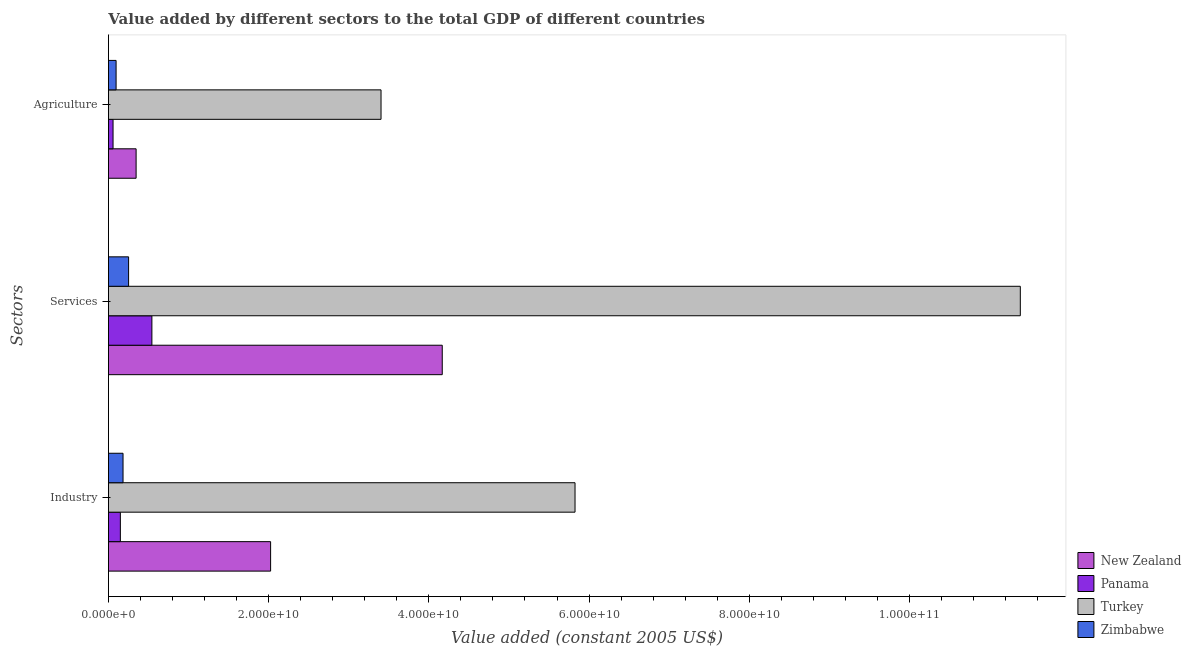Are the number of bars per tick equal to the number of legend labels?
Offer a very short reply. Yes. Are the number of bars on each tick of the Y-axis equal?
Your response must be concise. Yes. How many bars are there on the 3rd tick from the bottom?
Offer a terse response. 4. What is the label of the 1st group of bars from the top?
Keep it short and to the point. Agriculture. What is the value added by services in New Zealand?
Offer a very short reply. 4.17e+1. Across all countries, what is the maximum value added by agricultural sector?
Keep it short and to the point. 3.40e+1. Across all countries, what is the minimum value added by services?
Your answer should be compact. 2.52e+09. In which country was the value added by agricultural sector maximum?
Offer a very short reply. Turkey. In which country was the value added by agricultural sector minimum?
Your answer should be compact. Panama. What is the total value added by agricultural sector in the graph?
Provide a succinct answer. 3.90e+1. What is the difference between the value added by industrial sector in Zimbabwe and that in New Zealand?
Your response must be concise. -1.84e+1. What is the difference between the value added by industrial sector in Turkey and the value added by agricultural sector in Zimbabwe?
Offer a terse response. 5.73e+1. What is the average value added by industrial sector per country?
Your answer should be very brief. 2.05e+1. What is the difference between the value added by agricultural sector and value added by services in Turkey?
Your answer should be very brief. -7.98e+1. In how many countries, is the value added by agricultural sector greater than 64000000000 US$?
Your answer should be very brief. 0. What is the ratio of the value added by industrial sector in Zimbabwe to that in Panama?
Give a very brief answer. 1.22. Is the difference between the value added by agricultural sector in Zimbabwe and New Zealand greater than the difference between the value added by services in Zimbabwe and New Zealand?
Offer a terse response. Yes. What is the difference between the highest and the second highest value added by services?
Your answer should be compact. 7.22e+1. What is the difference between the highest and the lowest value added by services?
Your answer should be compact. 1.11e+11. In how many countries, is the value added by industrial sector greater than the average value added by industrial sector taken over all countries?
Offer a terse response. 1. What does the 1st bar from the top in Services represents?
Your answer should be compact. Zimbabwe. What does the 4th bar from the bottom in Industry represents?
Your response must be concise. Zimbabwe. Is it the case that in every country, the sum of the value added by industrial sector and value added by services is greater than the value added by agricultural sector?
Offer a terse response. Yes. How many bars are there?
Your response must be concise. 12. Are the values on the major ticks of X-axis written in scientific E-notation?
Offer a very short reply. Yes. Does the graph contain grids?
Provide a succinct answer. No. Where does the legend appear in the graph?
Offer a very short reply. Bottom right. How many legend labels are there?
Provide a succinct answer. 4. How are the legend labels stacked?
Offer a very short reply. Vertical. What is the title of the graph?
Provide a succinct answer. Value added by different sectors to the total GDP of different countries. What is the label or title of the X-axis?
Provide a succinct answer. Value added (constant 2005 US$). What is the label or title of the Y-axis?
Your answer should be very brief. Sectors. What is the Value added (constant 2005 US$) of New Zealand in Industry?
Keep it short and to the point. 2.02e+1. What is the Value added (constant 2005 US$) in Panama in Industry?
Your answer should be very brief. 1.49e+09. What is the Value added (constant 2005 US$) in Turkey in Industry?
Keep it short and to the point. 5.82e+1. What is the Value added (constant 2005 US$) of Zimbabwe in Industry?
Make the answer very short. 1.82e+09. What is the Value added (constant 2005 US$) in New Zealand in Services?
Keep it short and to the point. 4.17e+1. What is the Value added (constant 2005 US$) of Panama in Services?
Provide a succinct answer. 5.43e+09. What is the Value added (constant 2005 US$) of Turkey in Services?
Your response must be concise. 1.14e+11. What is the Value added (constant 2005 US$) of Zimbabwe in Services?
Offer a very short reply. 2.52e+09. What is the Value added (constant 2005 US$) in New Zealand in Agriculture?
Keep it short and to the point. 3.45e+09. What is the Value added (constant 2005 US$) in Panama in Agriculture?
Your answer should be compact. 5.77e+08. What is the Value added (constant 2005 US$) of Turkey in Agriculture?
Give a very brief answer. 3.40e+1. What is the Value added (constant 2005 US$) of Zimbabwe in Agriculture?
Your response must be concise. 9.56e+08. Across all Sectors, what is the maximum Value added (constant 2005 US$) in New Zealand?
Ensure brevity in your answer.  4.17e+1. Across all Sectors, what is the maximum Value added (constant 2005 US$) of Panama?
Make the answer very short. 5.43e+09. Across all Sectors, what is the maximum Value added (constant 2005 US$) in Turkey?
Give a very brief answer. 1.14e+11. Across all Sectors, what is the maximum Value added (constant 2005 US$) in Zimbabwe?
Give a very brief answer. 2.52e+09. Across all Sectors, what is the minimum Value added (constant 2005 US$) in New Zealand?
Offer a terse response. 3.45e+09. Across all Sectors, what is the minimum Value added (constant 2005 US$) in Panama?
Ensure brevity in your answer.  5.77e+08. Across all Sectors, what is the minimum Value added (constant 2005 US$) in Turkey?
Your answer should be compact. 3.40e+1. Across all Sectors, what is the minimum Value added (constant 2005 US$) in Zimbabwe?
Your answer should be compact. 9.56e+08. What is the total Value added (constant 2005 US$) in New Zealand in the graph?
Keep it short and to the point. 6.54e+1. What is the total Value added (constant 2005 US$) of Panama in the graph?
Provide a succinct answer. 7.49e+09. What is the total Value added (constant 2005 US$) of Turkey in the graph?
Your response must be concise. 2.06e+11. What is the total Value added (constant 2005 US$) in Zimbabwe in the graph?
Keep it short and to the point. 5.30e+09. What is the difference between the Value added (constant 2005 US$) in New Zealand in Industry and that in Services?
Provide a short and direct response. -2.14e+1. What is the difference between the Value added (constant 2005 US$) in Panama in Industry and that in Services?
Keep it short and to the point. -3.94e+09. What is the difference between the Value added (constant 2005 US$) in Turkey in Industry and that in Services?
Provide a short and direct response. -5.56e+1. What is the difference between the Value added (constant 2005 US$) of Zimbabwe in Industry and that in Services?
Make the answer very short. -6.93e+08. What is the difference between the Value added (constant 2005 US$) in New Zealand in Industry and that in Agriculture?
Make the answer very short. 1.68e+1. What is the difference between the Value added (constant 2005 US$) of Panama in Industry and that in Agriculture?
Your response must be concise. 9.13e+08. What is the difference between the Value added (constant 2005 US$) of Turkey in Industry and that in Agriculture?
Make the answer very short. 2.42e+1. What is the difference between the Value added (constant 2005 US$) in Zimbabwe in Industry and that in Agriculture?
Your response must be concise. 8.67e+08. What is the difference between the Value added (constant 2005 US$) in New Zealand in Services and that in Agriculture?
Ensure brevity in your answer.  3.82e+1. What is the difference between the Value added (constant 2005 US$) in Panama in Services and that in Agriculture?
Give a very brief answer. 4.85e+09. What is the difference between the Value added (constant 2005 US$) of Turkey in Services and that in Agriculture?
Your answer should be compact. 7.98e+1. What is the difference between the Value added (constant 2005 US$) in Zimbabwe in Services and that in Agriculture?
Provide a short and direct response. 1.56e+09. What is the difference between the Value added (constant 2005 US$) of New Zealand in Industry and the Value added (constant 2005 US$) of Panama in Services?
Give a very brief answer. 1.48e+1. What is the difference between the Value added (constant 2005 US$) of New Zealand in Industry and the Value added (constant 2005 US$) of Turkey in Services?
Ensure brevity in your answer.  -9.36e+1. What is the difference between the Value added (constant 2005 US$) of New Zealand in Industry and the Value added (constant 2005 US$) of Zimbabwe in Services?
Offer a terse response. 1.77e+1. What is the difference between the Value added (constant 2005 US$) of Panama in Industry and the Value added (constant 2005 US$) of Turkey in Services?
Your answer should be very brief. -1.12e+11. What is the difference between the Value added (constant 2005 US$) of Panama in Industry and the Value added (constant 2005 US$) of Zimbabwe in Services?
Your answer should be compact. -1.03e+09. What is the difference between the Value added (constant 2005 US$) of Turkey in Industry and the Value added (constant 2005 US$) of Zimbabwe in Services?
Your answer should be compact. 5.57e+1. What is the difference between the Value added (constant 2005 US$) of New Zealand in Industry and the Value added (constant 2005 US$) of Panama in Agriculture?
Your answer should be compact. 1.97e+1. What is the difference between the Value added (constant 2005 US$) in New Zealand in Industry and the Value added (constant 2005 US$) in Turkey in Agriculture?
Keep it short and to the point. -1.38e+1. What is the difference between the Value added (constant 2005 US$) of New Zealand in Industry and the Value added (constant 2005 US$) of Zimbabwe in Agriculture?
Offer a terse response. 1.93e+1. What is the difference between the Value added (constant 2005 US$) of Panama in Industry and the Value added (constant 2005 US$) of Turkey in Agriculture?
Provide a succinct answer. -3.25e+1. What is the difference between the Value added (constant 2005 US$) of Panama in Industry and the Value added (constant 2005 US$) of Zimbabwe in Agriculture?
Make the answer very short. 5.34e+08. What is the difference between the Value added (constant 2005 US$) of Turkey in Industry and the Value added (constant 2005 US$) of Zimbabwe in Agriculture?
Ensure brevity in your answer.  5.73e+1. What is the difference between the Value added (constant 2005 US$) of New Zealand in Services and the Value added (constant 2005 US$) of Panama in Agriculture?
Ensure brevity in your answer.  4.11e+1. What is the difference between the Value added (constant 2005 US$) in New Zealand in Services and the Value added (constant 2005 US$) in Turkey in Agriculture?
Keep it short and to the point. 7.64e+09. What is the difference between the Value added (constant 2005 US$) in New Zealand in Services and the Value added (constant 2005 US$) in Zimbabwe in Agriculture?
Offer a terse response. 4.07e+1. What is the difference between the Value added (constant 2005 US$) in Panama in Services and the Value added (constant 2005 US$) in Turkey in Agriculture?
Your answer should be compact. -2.86e+1. What is the difference between the Value added (constant 2005 US$) of Panama in Services and the Value added (constant 2005 US$) of Zimbabwe in Agriculture?
Give a very brief answer. 4.47e+09. What is the difference between the Value added (constant 2005 US$) of Turkey in Services and the Value added (constant 2005 US$) of Zimbabwe in Agriculture?
Your answer should be very brief. 1.13e+11. What is the average Value added (constant 2005 US$) of New Zealand per Sectors?
Provide a short and direct response. 2.18e+1. What is the average Value added (constant 2005 US$) of Panama per Sectors?
Provide a short and direct response. 2.50e+09. What is the average Value added (constant 2005 US$) in Turkey per Sectors?
Offer a terse response. 6.87e+1. What is the average Value added (constant 2005 US$) in Zimbabwe per Sectors?
Your answer should be very brief. 1.77e+09. What is the difference between the Value added (constant 2005 US$) in New Zealand and Value added (constant 2005 US$) in Panama in Industry?
Provide a succinct answer. 1.88e+1. What is the difference between the Value added (constant 2005 US$) in New Zealand and Value added (constant 2005 US$) in Turkey in Industry?
Offer a very short reply. -3.80e+1. What is the difference between the Value added (constant 2005 US$) of New Zealand and Value added (constant 2005 US$) of Zimbabwe in Industry?
Provide a short and direct response. 1.84e+1. What is the difference between the Value added (constant 2005 US$) in Panama and Value added (constant 2005 US$) in Turkey in Industry?
Offer a very short reply. -5.68e+1. What is the difference between the Value added (constant 2005 US$) of Panama and Value added (constant 2005 US$) of Zimbabwe in Industry?
Your response must be concise. -3.33e+08. What is the difference between the Value added (constant 2005 US$) of Turkey and Value added (constant 2005 US$) of Zimbabwe in Industry?
Give a very brief answer. 5.64e+1. What is the difference between the Value added (constant 2005 US$) of New Zealand and Value added (constant 2005 US$) of Panama in Services?
Give a very brief answer. 3.62e+1. What is the difference between the Value added (constant 2005 US$) in New Zealand and Value added (constant 2005 US$) in Turkey in Services?
Provide a succinct answer. -7.22e+1. What is the difference between the Value added (constant 2005 US$) of New Zealand and Value added (constant 2005 US$) of Zimbabwe in Services?
Your answer should be very brief. 3.92e+1. What is the difference between the Value added (constant 2005 US$) of Panama and Value added (constant 2005 US$) of Turkey in Services?
Offer a very short reply. -1.08e+11. What is the difference between the Value added (constant 2005 US$) of Panama and Value added (constant 2005 US$) of Zimbabwe in Services?
Your answer should be very brief. 2.91e+09. What is the difference between the Value added (constant 2005 US$) in Turkey and Value added (constant 2005 US$) in Zimbabwe in Services?
Make the answer very short. 1.11e+11. What is the difference between the Value added (constant 2005 US$) in New Zealand and Value added (constant 2005 US$) in Panama in Agriculture?
Your answer should be very brief. 2.88e+09. What is the difference between the Value added (constant 2005 US$) in New Zealand and Value added (constant 2005 US$) in Turkey in Agriculture?
Your answer should be very brief. -3.06e+1. What is the difference between the Value added (constant 2005 US$) in New Zealand and Value added (constant 2005 US$) in Zimbabwe in Agriculture?
Offer a terse response. 2.50e+09. What is the difference between the Value added (constant 2005 US$) in Panama and Value added (constant 2005 US$) in Turkey in Agriculture?
Your answer should be compact. -3.35e+1. What is the difference between the Value added (constant 2005 US$) in Panama and Value added (constant 2005 US$) in Zimbabwe in Agriculture?
Provide a succinct answer. -3.79e+08. What is the difference between the Value added (constant 2005 US$) in Turkey and Value added (constant 2005 US$) in Zimbabwe in Agriculture?
Provide a succinct answer. 3.31e+1. What is the ratio of the Value added (constant 2005 US$) in New Zealand in Industry to that in Services?
Provide a succinct answer. 0.49. What is the ratio of the Value added (constant 2005 US$) of Panama in Industry to that in Services?
Give a very brief answer. 0.27. What is the ratio of the Value added (constant 2005 US$) in Turkey in Industry to that in Services?
Provide a short and direct response. 0.51. What is the ratio of the Value added (constant 2005 US$) of Zimbabwe in Industry to that in Services?
Offer a terse response. 0.72. What is the ratio of the Value added (constant 2005 US$) in New Zealand in Industry to that in Agriculture?
Your answer should be very brief. 5.86. What is the ratio of the Value added (constant 2005 US$) in Panama in Industry to that in Agriculture?
Ensure brevity in your answer.  2.58. What is the ratio of the Value added (constant 2005 US$) of Turkey in Industry to that in Agriculture?
Your answer should be very brief. 1.71. What is the ratio of the Value added (constant 2005 US$) of Zimbabwe in Industry to that in Agriculture?
Your answer should be very brief. 1.91. What is the ratio of the Value added (constant 2005 US$) in New Zealand in Services to that in Agriculture?
Offer a very short reply. 12.06. What is the ratio of the Value added (constant 2005 US$) of Panama in Services to that in Agriculture?
Give a very brief answer. 9.4. What is the ratio of the Value added (constant 2005 US$) of Turkey in Services to that in Agriculture?
Your response must be concise. 3.35. What is the ratio of the Value added (constant 2005 US$) of Zimbabwe in Services to that in Agriculture?
Offer a terse response. 2.63. What is the difference between the highest and the second highest Value added (constant 2005 US$) in New Zealand?
Offer a terse response. 2.14e+1. What is the difference between the highest and the second highest Value added (constant 2005 US$) in Panama?
Provide a succinct answer. 3.94e+09. What is the difference between the highest and the second highest Value added (constant 2005 US$) in Turkey?
Your response must be concise. 5.56e+1. What is the difference between the highest and the second highest Value added (constant 2005 US$) in Zimbabwe?
Your answer should be very brief. 6.93e+08. What is the difference between the highest and the lowest Value added (constant 2005 US$) of New Zealand?
Provide a short and direct response. 3.82e+1. What is the difference between the highest and the lowest Value added (constant 2005 US$) in Panama?
Your answer should be compact. 4.85e+09. What is the difference between the highest and the lowest Value added (constant 2005 US$) in Turkey?
Your response must be concise. 7.98e+1. What is the difference between the highest and the lowest Value added (constant 2005 US$) in Zimbabwe?
Make the answer very short. 1.56e+09. 